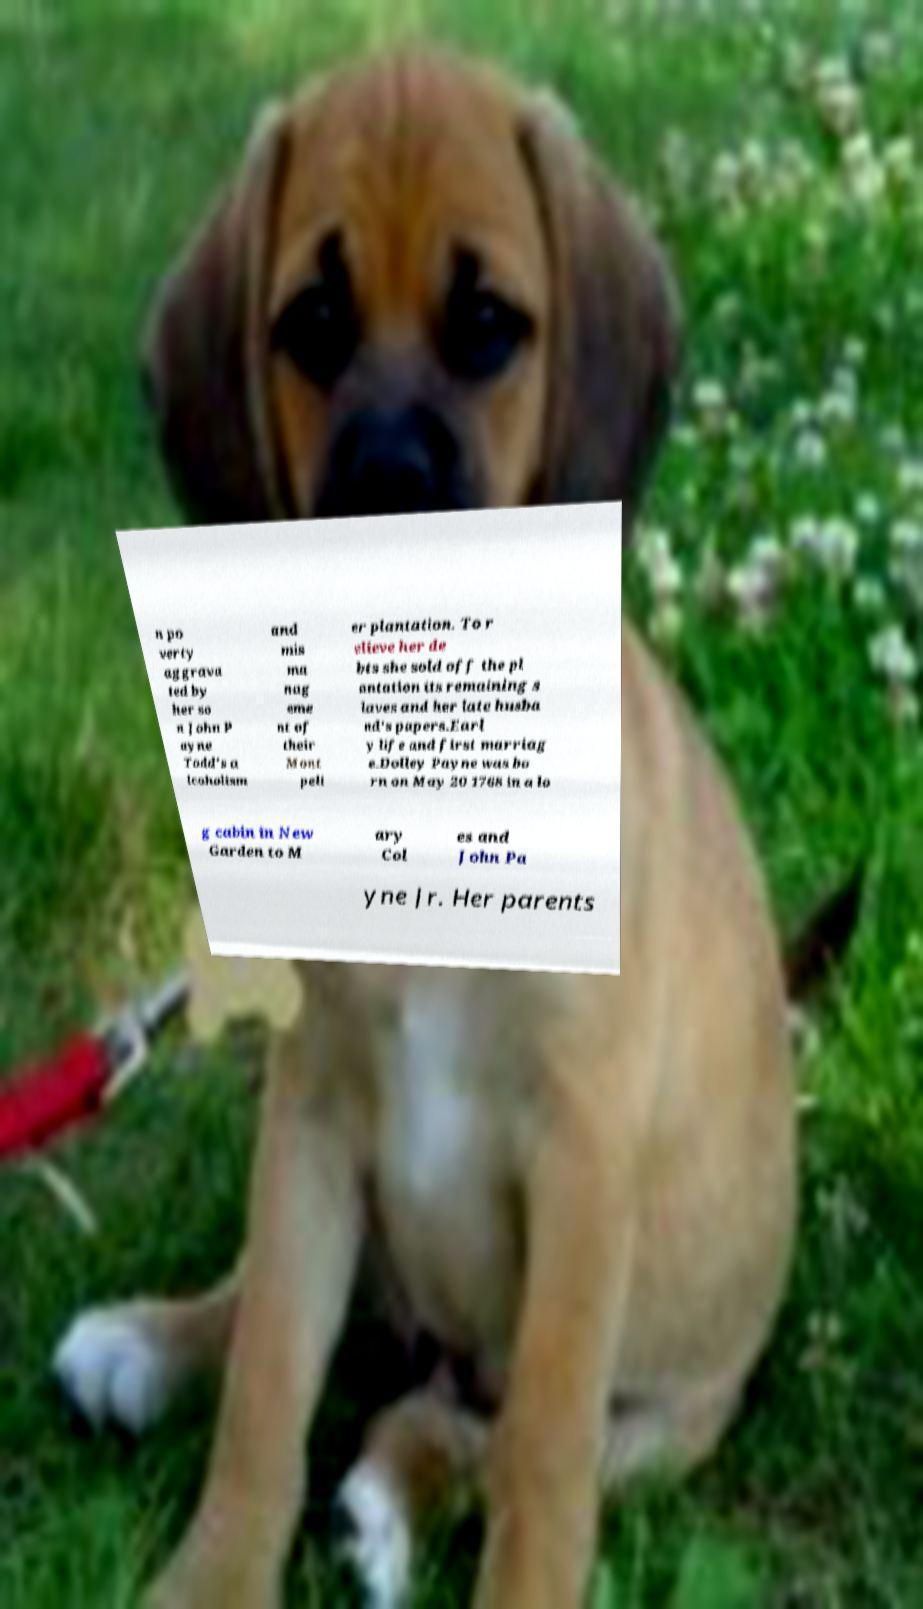Could you assist in decoding the text presented in this image and type it out clearly? n po verty aggrava ted by her so n John P ayne Todd's a lcoholism and mis ma nag eme nt of their Mont peli er plantation. To r elieve her de bts she sold off the pl antation its remaining s laves and her late husba nd's papers.Earl y life and first marriag e.Dolley Payne was bo rn on May 20 1768 in a lo g cabin in New Garden to M ary Col es and John Pa yne Jr. Her parents 